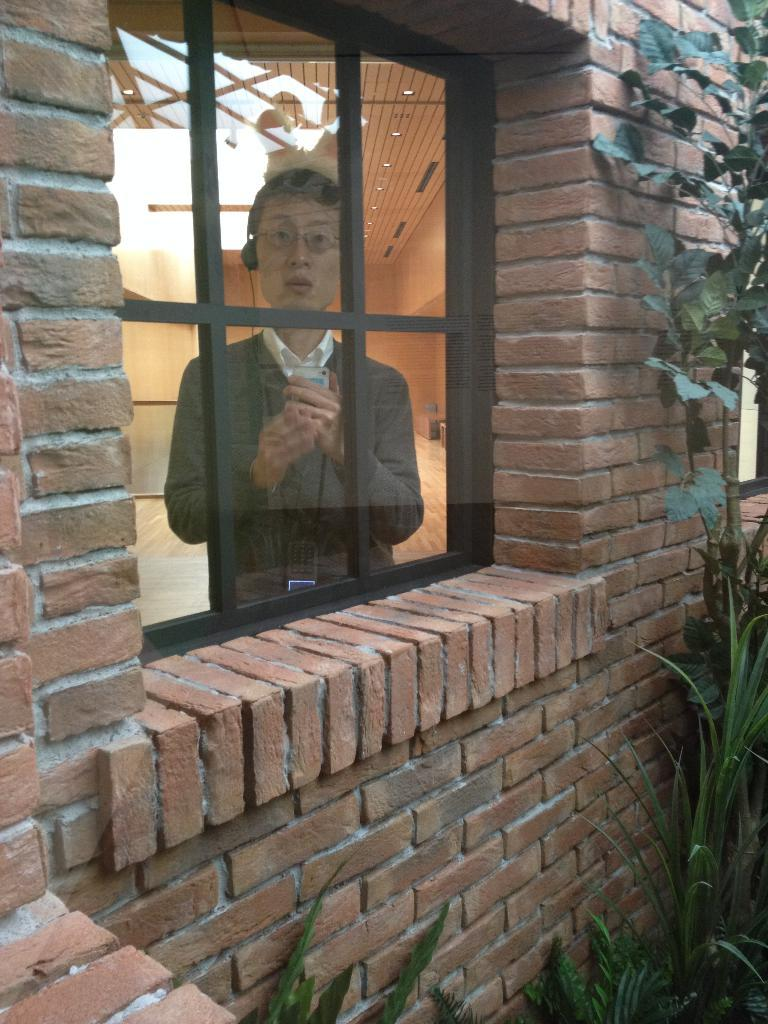What type of structure is visible in the image? There is a brick wall in the image. What can be seen in the brick wall? There is a glass window in the image. Who is present near the window? A man is standing at the window. What type of vegetation is visible in the image? There are plants visible in the image. What type of yarn is the man using to kick the plants in the image? There is no yarn or kicking action present in the image. The man is simply standing at the window, and the plants are not being interacted with. 